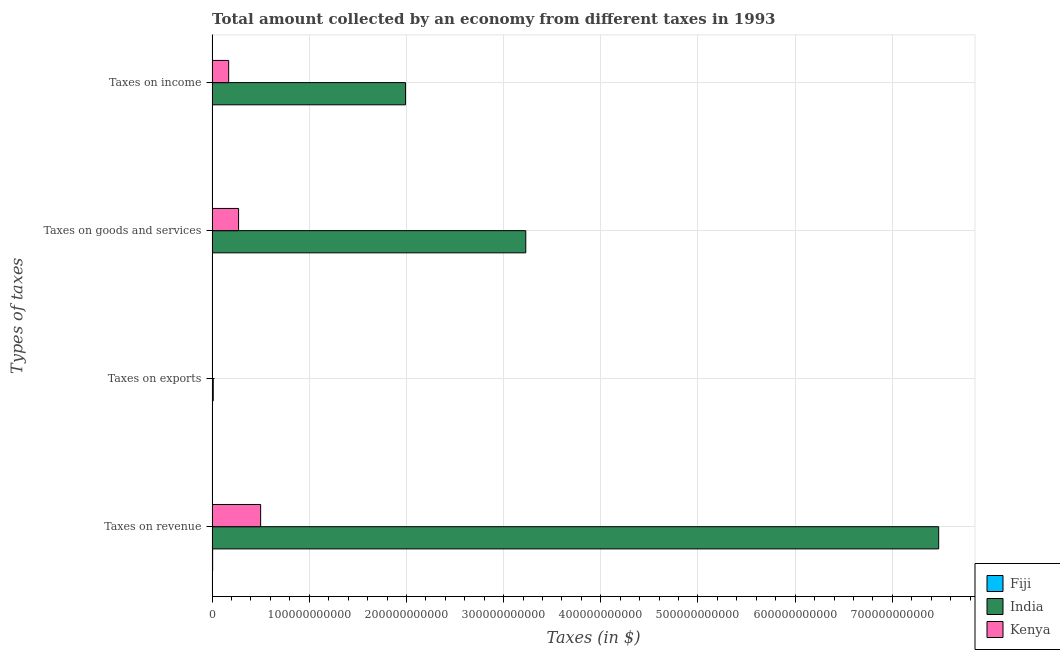How many different coloured bars are there?
Provide a succinct answer. 3. Are the number of bars per tick equal to the number of legend labels?
Offer a terse response. Yes. How many bars are there on the 4th tick from the bottom?
Keep it short and to the point. 3. What is the label of the 3rd group of bars from the top?
Keep it short and to the point. Taxes on exports. What is the amount collected as tax on income in Fiji?
Give a very brief answer. 1.91e+08. Across all countries, what is the maximum amount collected as tax on goods?
Offer a terse response. 3.23e+11. Across all countries, what is the minimum amount collected as tax on goods?
Offer a very short reply. 2.04e+08. In which country was the amount collected as tax on goods minimum?
Offer a terse response. Fiji. What is the total amount collected as tax on revenue in the graph?
Offer a terse response. 7.98e+11. What is the difference between the amount collected as tax on goods in Fiji and that in Kenya?
Offer a very short reply. -2.70e+1. What is the difference between the amount collected as tax on exports in Fiji and the amount collected as tax on revenue in Kenya?
Make the answer very short. -4.99e+1. What is the average amount collected as tax on income per country?
Give a very brief answer. 7.21e+1. What is the difference between the amount collected as tax on exports and amount collected as tax on income in India?
Your response must be concise. -1.98e+11. In how many countries, is the amount collected as tax on goods greater than 320000000000 $?
Keep it short and to the point. 1. What is the ratio of the amount collected as tax on exports in Kenya to that in Fiji?
Keep it short and to the point. 0.11. Is the amount collected as tax on exports in Kenya less than that in India?
Your response must be concise. Yes. Is the difference between the amount collected as tax on revenue in Kenya and Fiji greater than the difference between the amount collected as tax on income in Kenya and Fiji?
Provide a short and direct response. Yes. What is the difference between the highest and the second highest amount collected as tax on exports?
Provide a succinct answer. 1.14e+09. What is the difference between the highest and the lowest amount collected as tax on income?
Keep it short and to the point. 1.99e+11. What does the 1st bar from the top in Taxes on goods and services represents?
Your answer should be very brief. Kenya. What does the 3rd bar from the bottom in Taxes on income represents?
Your response must be concise. Kenya. Is it the case that in every country, the sum of the amount collected as tax on revenue and amount collected as tax on exports is greater than the amount collected as tax on goods?
Give a very brief answer. Yes. How many bars are there?
Keep it short and to the point. 12. Are all the bars in the graph horizontal?
Your response must be concise. Yes. How many countries are there in the graph?
Make the answer very short. 3. What is the difference between two consecutive major ticks on the X-axis?
Make the answer very short. 1.00e+11. Does the graph contain any zero values?
Ensure brevity in your answer.  No. Does the graph contain grids?
Your answer should be very brief. Yes. How many legend labels are there?
Offer a terse response. 3. How are the legend labels stacked?
Provide a succinct answer. Vertical. What is the title of the graph?
Ensure brevity in your answer.  Total amount collected by an economy from different taxes in 1993. What is the label or title of the X-axis?
Offer a terse response. Taxes (in $). What is the label or title of the Y-axis?
Ensure brevity in your answer.  Types of taxes. What is the Taxes (in $) of Fiji in Taxes on revenue?
Keep it short and to the point. 5.40e+08. What is the Taxes (in $) of India in Taxes on revenue?
Your answer should be very brief. 7.48e+11. What is the Taxes (in $) in Kenya in Taxes on revenue?
Provide a succinct answer. 4.99e+1. What is the Taxes (in $) of Fiji in Taxes on exports?
Offer a very short reply. 9.08e+06. What is the Taxes (in $) of India in Taxes on exports?
Offer a terse response. 1.15e+09. What is the Taxes (in $) in Kenya in Taxes on exports?
Keep it short and to the point. 1.00e+06. What is the Taxes (in $) in Fiji in Taxes on goods and services?
Offer a very short reply. 2.04e+08. What is the Taxes (in $) of India in Taxes on goods and services?
Keep it short and to the point. 3.23e+11. What is the Taxes (in $) in Kenya in Taxes on goods and services?
Provide a short and direct response. 2.72e+1. What is the Taxes (in $) of Fiji in Taxes on income?
Provide a succinct answer. 1.91e+08. What is the Taxes (in $) in India in Taxes on income?
Provide a short and direct response. 1.99e+11. What is the Taxes (in $) of Kenya in Taxes on income?
Your answer should be compact. 1.70e+1. Across all Types of taxes, what is the maximum Taxes (in $) of Fiji?
Ensure brevity in your answer.  5.40e+08. Across all Types of taxes, what is the maximum Taxes (in $) of India?
Provide a succinct answer. 7.48e+11. Across all Types of taxes, what is the maximum Taxes (in $) in Kenya?
Provide a succinct answer. 4.99e+1. Across all Types of taxes, what is the minimum Taxes (in $) of Fiji?
Provide a short and direct response. 9.08e+06. Across all Types of taxes, what is the minimum Taxes (in $) of India?
Keep it short and to the point. 1.15e+09. Across all Types of taxes, what is the minimum Taxes (in $) of Kenya?
Provide a short and direct response. 1.00e+06. What is the total Taxes (in $) in Fiji in the graph?
Provide a short and direct response. 9.44e+08. What is the total Taxes (in $) of India in the graph?
Give a very brief answer. 1.27e+12. What is the total Taxes (in $) in Kenya in the graph?
Your answer should be compact. 9.42e+1. What is the difference between the Taxes (in $) in Fiji in Taxes on revenue and that in Taxes on exports?
Your answer should be very brief. 5.31e+08. What is the difference between the Taxes (in $) of India in Taxes on revenue and that in Taxes on exports?
Provide a succinct answer. 7.47e+11. What is the difference between the Taxes (in $) in Kenya in Taxes on revenue and that in Taxes on exports?
Give a very brief answer. 4.99e+1. What is the difference between the Taxes (in $) in Fiji in Taxes on revenue and that in Taxes on goods and services?
Keep it short and to the point. 3.36e+08. What is the difference between the Taxes (in $) in India in Taxes on revenue and that in Taxes on goods and services?
Your answer should be very brief. 4.25e+11. What is the difference between the Taxes (in $) in Kenya in Taxes on revenue and that in Taxes on goods and services?
Provide a short and direct response. 2.27e+1. What is the difference between the Taxes (in $) of Fiji in Taxes on revenue and that in Taxes on income?
Ensure brevity in your answer.  3.49e+08. What is the difference between the Taxes (in $) of India in Taxes on revenue and that in Taxes on income?
Make the answer very short. 5.49e+11. What is the difference between the Taxes (in $) in Kenya in Taxes on revenue and that in Taxes on income?
Your answer should be very brief. 3.29e+1. What is the difference between the Taxes (in $) in Fiji in Taxes on exports and that in Taxes on goods and services?
Keep it short and to the point. -1.95e+08. What is the difference between the Taxes (in $) in India in Taxes on exports and that in Taxes on goods and services?
Keep it short and to the point. -3.22e+11. What is the difference between the Taxes (in $) of Kenya in Taxes on exports and that in Taxes on goods and services?
Provide a succinct answer. -2.72e+1. What is the difference between the Taxes (in $) of Fiji in Taxes on exports and that in Taxes on income?
Provide a succinct answer. -1.82e+08. What is the difference between the Taxes (in $) in India in Taxes on exports and that in Taxes on income?
Ensure brevity in your answer.  -1.98e+11. What is the difference between the Taxes (in $) in Kenya in Taxes on exports and that in Taxes on income?
Provide a short and direct response. -1.70e+1. What is the difference between the Taxes (in $) of Fiji in Taxes on goods and services and that in Taxes on income?
Offer a terse response. 1.30e+07. What is the difference between the Taxes (in $) of India in Taxes on goods and services and that in Taxes on income?
Give a very brief answer. 1.24e+11. What is the difference between the Taxes (in $) of Kenya in Taxes on goods and services and that in Taxes on income?
Your answer should be compact. 1.02e+1. What is the difference between the Taxes (in $) of Fiji in Taxes on revenue and the Taxes (in $) of India in Taxes on exports?
Provide a short and direct response. -6.10e+08. What is the difference between the Taxes (in $) in Fiji in Taxes on revenue and the Taxes (in $) in Kenya in Taxes on exports?
Provide a short and direct response. 5.39e+08. What is the difference between the Taxes (in $) of India in Taxes on revenue and the Taxes (in $) of Kenya in Taxes on exports?
Give a very brief answer. 7.48e+11. What is the difference between the Taxes (in $) in Fiji in Taxes on revenue and the Taxes (in $) in India in Taxes on goods and services?
Keep it short and to the point. -3.22e+11. What is the difference between the Taxes (in $) in Fiji in Taxes on revenue and the Taxes (in $) in Kenya in Taxes on goods and services?
Make the answer very short. -2.67e+1. What is the difference between the Taxes (in $) in India in Taxes on revenue and the Taxes (in $) in Kenya in Taxes on goods and services?
Offer a terse response. 7.20e+11. What is the difference between the Taxes (in $) of Fiji in Taxes on revenue and the Taxes (in $) of India in Taxes on income?
Provide a short and direct response. -1.98e+11. What is the difference between the Taxes (in $) of Fiji in Taxes on revenue and the Taxes (in $) of Kenya in Taxes on income?
Offer a very short reply. -1.65e+1. What is the difference between the Taxes (in $) of India in Taxes on revenue and the Taxes (in $) of Kenya in Taxes on income?
Provide a succinct answer. 7.31e+11. What is the difference between the Taxes (in $) in Fiji in Taxes on exports and the Taxes (in $) in India in Taxes on goods and services?
Provide a short and direct response. -3.23e+11. What is the difference between the Taxes (in $) of Fiji in Taxes on exports and the Taxes (in $) of Kenya in Taxes on goods and services?
Your answer should be compact. -2.72e+1. What is the difference between the Taxes (in $) of India in Taxes on exports and the Taxes (in $) of Kenya in Taxes on goods and services?
Ensure brevity in your answer.  -2.61e+1. What is the difference between the Taxes (in $) in Fiji in Taxes on exports and the Taxes (in $) in India in Taxes on income?
Give a very brief answer. -1.99e+11. What is the difference between the Taxes (in $) of Fiji in Taxes on exports and the Taxes (in $) of Kenya in Taxes on income?
Offer a terse response. -1.70e+1. What is the difference between the Taxes (in $) of India in Taxes on exports and the Taxes (in $) of Kenya in Taxes on income?
Ensure brevity in your answer.  -1.59e+1. What is the difference between the Taxes (in $) in Fiji in Taxes on goods and services and the Taxes (in $) in India in Taxes on income?
Provide a short and direct response. -1.99e+11. What is the difference between the Taxes (in $) of Fiji in Taxes on goods and services and the Taxes (in $) of Kenya in Taxes on income?
Offer a very short reply. -1.68e+1. What is the difference between the Taxes (in $) of India in Taxes on goods and services and the Taxes (in $) of Kenya in Taxes on income?
Your response must be concise. 3.06e+11. What is the average Taxes (in $) in Fiji per Types of taxes?
Give a very brief answer. 2.36e+08. What is the average Taxes (in $) of India per Types of taxes?
Your answer should be compact. 3.18e+11. What is the average Taxes (in $) of Kenya per Types of taxes?
Provide a short and direct response. 2.35e+1. What is the difference between the Taxes (in $) in Fiji and Taxes (in $) in India in Taxes on revenue?
Offer a terse response. -7.47e+11. What is the difference between the Taxes (in $) of Fiji and Taxes (in $) of Kenya in Taxes on revenue?
Give a very brief answer. -4.94e+1. What is the difference between the Taxes (in $) in India and Taxes (in $) in Kenya in Taxes on revenue?
Make the answer very short. 6.98e+11. What is the difference between the Taxes (in $) of Fiji and Taxes (in $) of India in Taxes on exports?
Provide a short and direct response. -1.14e+09. What is the difference between the Taxes (in $) in Fiji and Taxes (in $) in Kenya in Taxes on exports?
Make the answer very short. 8.08e+06. What is the difference between the Taxes (in $) in India and Taxes (in $) in Kenya in Taxes on exports?
Provide a short and direct response. 1.15e+09. What is the difference between the Taxes (in $) of Fiji and Taxes (in $) of India in Taxes on goods and services?
Your response must be concise. -3.23e+11. What is the difference between the Taxes (in $) in Fiji and Taxes (in $) in Kenya in Taxes on goods and services?
Give a very brief answer. -2.70e+1. What is the difference between the Taxes (in $) of India and Taxes (in $) of Kenya in Taxes on goods and services?
Ensure brevity in your answer.  2.96e+11. What is the difference between the Taxes (in $) of Fiji and Taxes (in $) of India in Taxes on income?
Offer a very short reply. -1.99e+11. What is the difference between the Taxes (in $) of Fiji and Taxes (in $) of Kenya in Taxes on income?
Your answer should be compact. -1.68e+1. What is the difference between the Taxes (in $) in India and Taxes (in $) in Kenya in Taxes on income?
Offer a terse response. 1.82e+11. What is the ratio of the Taxes (in $) in Fiji in Taxes on revenue to that in Taxes on exports?
Ensure brevity in your answer.  59.46. What is the ratio of the Taxes (in $) of India in Taxes on revenue to that in Taxes on exports?
Offer a terse response. 650.16. What is the ratio of the Taxes (in $) in Kenya in Taxes on revenue to that in Taxes on exports?
Keep it short and to the point. 4.99e+04. What is the ratio of the Taxes (in $) of Fiji in Taxes on revenue to that in Taxes on goods and services?
Make the answer very short. 2.64. What is the ratio of the Taxes (in $) in India in Taxes on revenue to that in Taxes on goods and services?
Your response must be concise. 2.32. What is the ratio of the Taxes (in $) of Kenya in Taxes on revenue to that in Taxes on goods and services?
Make the answer very short. 1.83. What is the ratio of the Taxes (in $) in Fiji in Taxes on revenue to that in Taxes on income?
Your answer should be very brief. 2.82. What is the ratio of the Taxes (in $) in India in Taxes on revenue to that in Taxes on income?
Make the answer very short. 3.76. What is the ratio of the Taxes (in $) in Kenya in Taxes on revenue to that in Taxes on income?
Your answer should be very brief. 2.93. What is the ratio of the Taxes (in $) of Fiji in Taxes on exports to that in Taxes on goods and services?
Provide a short and direct response. 0.04. What is the ratio of the Taxes (in $) in India in Taxes on exports to that in Taxes on goods and services?
Ensure brevity in your answer.  0. What is the ratio of the Taxes (in $) of Kenya in Taxes on exports to that in Taxes on goods and services?
Give a very brief answer. 0. What is the ratio of the Taxes (in $) of Fiji in Taxes on exports to that in Taxes on income?
Offer a terse response. 0.05. What is the ratio of the Taxes (in $) in India in Taxes on exports to that in Taxes on income?
Keep it short and to the point. 0.01. What is the ratio of the Taxes (in $) in Kenya in Taxes on exports to that in Taxes on income?
Your response must be concise. 0. What is the ratio of the Taxes (in $) in Fiji in Taxes on goods and services to that in Taxes on income?
Keep it short and to the point. 1.07. What is the ratio of the Taxes (in $) of India in Taxes on goods and services to that in Taxes on income?
Your answer should be compact. 1.62. What is the ratio of the Taxes (in $) in Kenya in Taxes on goods and services to that in Taxes on income?
Ensure brevity in your answer.  1.6. What is the difference between the highest and the second highest Taxes (in $) of Fiji?
Offer a terse response. 3.36e+08. What is the difference between the highest and the second highest Taxes (in $) of India?
Provide a short and direct response. 4.25e+11. What is the difference between the highest and the second highest Taxes (in $) of Kenya?
Make the answer very short. 2.27e+1. What is the difference between the highest and the lowest Taxes (in $) in Fiji?
Ensure brevity in your answer.  5.31e+08. What is the difference between the highest and the lowest Taxes (in $) in India?
Make the answer very short. 7.47e+11. What is the difference between the highest and the lowest Taxes (in $) of Kenya?
Offer a terse response. 4.99e+1. 